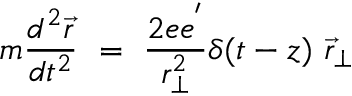Convert formula to latex. <formula><loc_0><loc_0><loc_500><loc_500>m { \frac { d ^ { 2 } \vec { r } } { d t ^ { 2 } } } = { \frac { 2 e e ^ { ^ { \prime } } } { r _ { \perp } ^ { 2 } } } \delta ( t - z { \vec { r } } _ { \perp }</formula> 